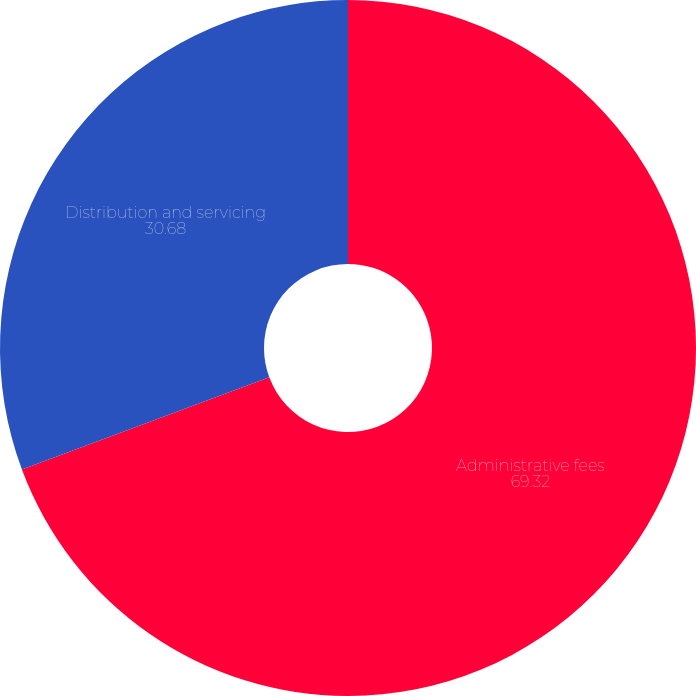<chart> <loc_0><loc_0><loc_500><loc_500><pie_chart><fcel>Administrative fees<fcel>Distribution and servicing<nl><fcel>69.32%<fcel>30.68%<nl></chart> 